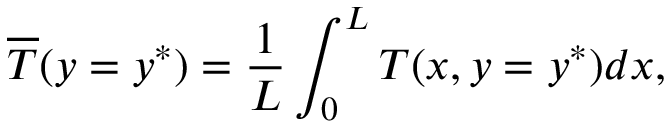<formula> <loc_0><loc_0><loc_500><loc_500>\overline { T } ( y = y ^ { * } ) = \frac { 1 } { L } \int _ { 0 } ^ { L } T ( x , y = y ^ { * } ) d x ,</formula> 